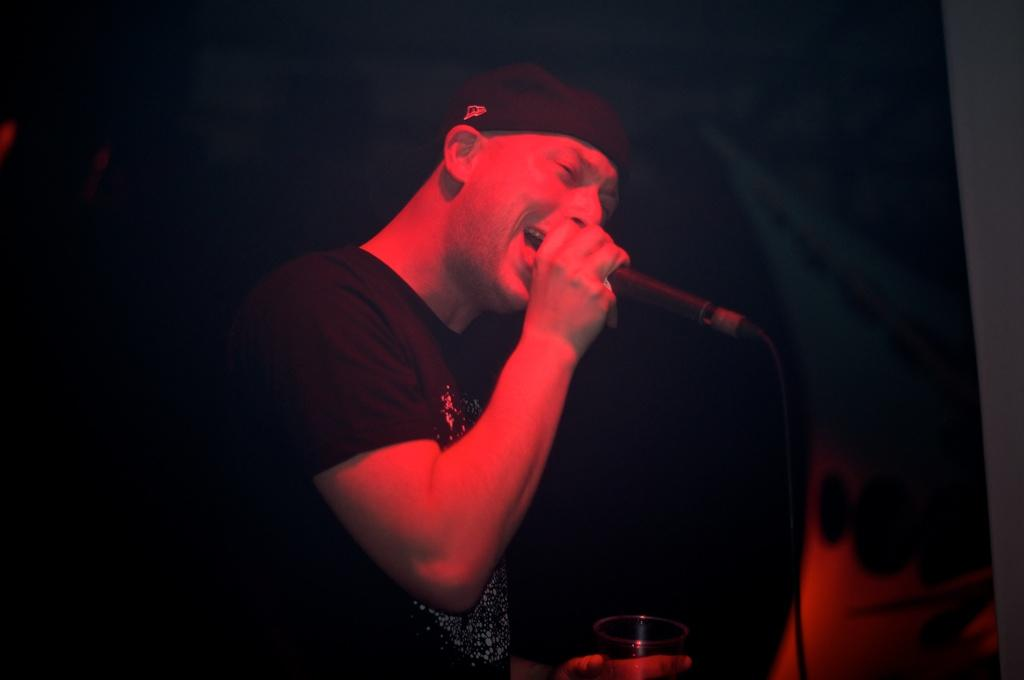What is the person in the image doing? The person is singing. What object is the person holding while singing? The person is holding a microphone. What other object is the person holding? The person is holding a wine glass. What color can be seen in the image? There is a black color visible in the image, possibly referring to a background or clothing. How many cherries are on the person's head in the image? There are no cherries visible on the person's head in the image. What type of thrill can be experienced by the person in the image? The image does not provide information about any specific thrill the person might be experiencing. 